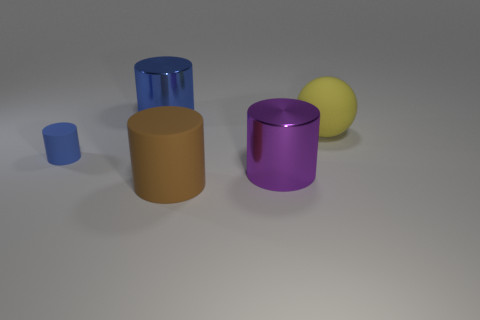What is the size of the other metal cylinder that is the same color as the small cylinder?
Provide a succinct answer. Large. The matte object on the right side of the big matte object in front of the small matte cylinder on the left side of the brown matte object is what color?
Your answer should be compact. Yellow. What color is the shiny object that is the same size as the purple cylinder?
Your answer should be compact. Blue. What is the shape of the large thing that is on the left side of the big thing that is in front of the cylinder that is right of the brown matte thing?
Offer a terse response. Cylinder. There is a metallic thing that is the same color as the tiny rubber thing; what is its shape?
Provide a short and direct response. Cylinder. How many objects are blue cylinders or blue cylinders in front of the large rubber sphere?
Your answer should be very brief. 2. There is a blue thing in front of the matte sphere; does it have the same size as the purple thing?
Your response must be concise. No. There is a blue cylinder behind the yellow matte sphere; what is its material?
Your answer should be very brief. Metal. Are there the same number of big yellow balls that are in front of the large purple metal thing and blue cylinders that are in front of the blue metallic thing?
Your answer should be very brief. No. What is the color of the tiny object that is the same shape as the big brown thing?
Your response must be concise. Blue. 